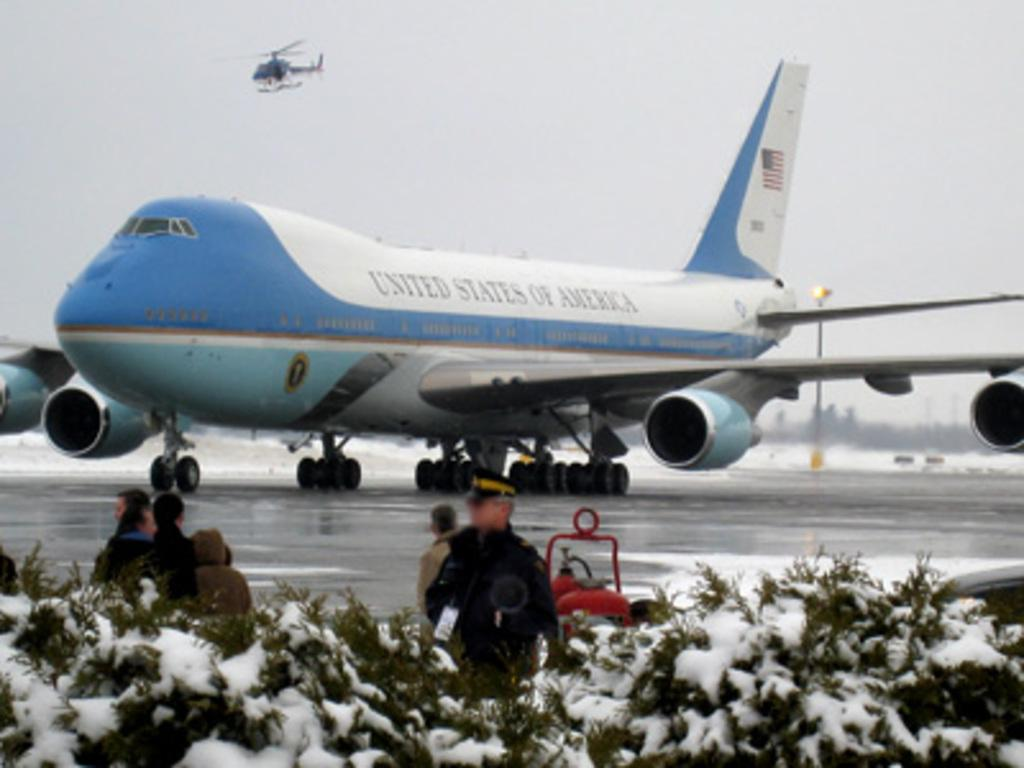<image>
Present a compact description of the photo's key features. The United States of America Air Force 1 on the runway. 